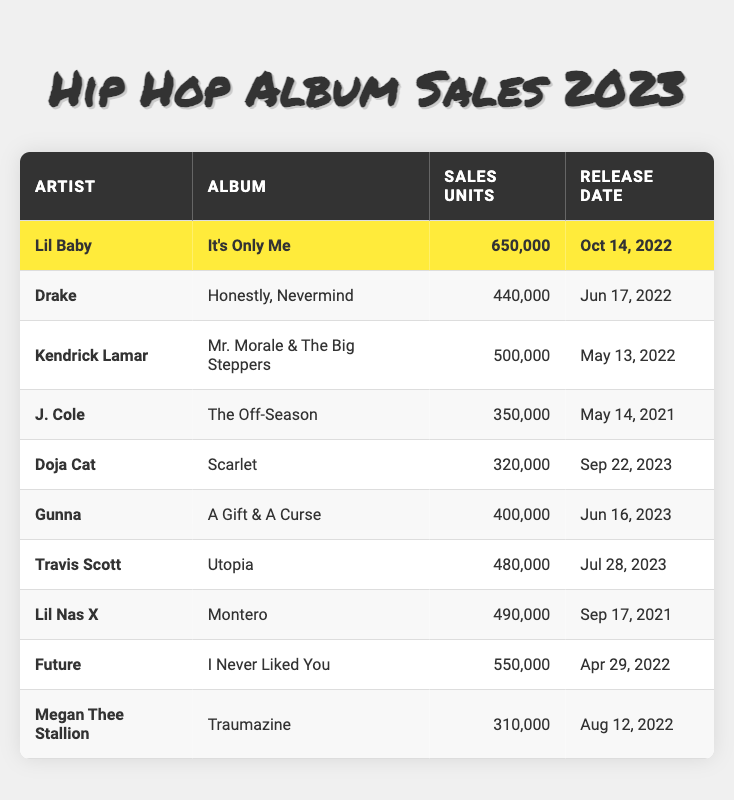What is the total number of sales units for all albums listed? To find the total sales units, I will sum the sales units for each album: 650,000 (Lil Baby) + 440,000 (Drake) + 500,000 (Kendrick Lamar) + 350,000 (J. Cole) + 320,000 (Doja Cat) + 400,000 (Gunna) + 480,000 (Travis Scott) + 490,000 (Lil Nas X) + 550,000 (Future) + 310,000 (Megan Thee Stallion) = 4,930,000.
Answer: 4,930,000 Which album had the highest sales units? Looking through the table, I can see that "It's Only Me" by Lil Baby has 650,000 sales units, which is more than any other album listed.
Answer: It's Only Me How many albums were released in 2023? By reviewing the release dates in the table, I see that there are three albums released in 2023: "Scarlet" by Doja Cat, "A Gift & A Curse" by Gunna, and "Utopia" by Travis Scott.
Answer: 3 True or False: Travis Scott's album has more sales than Megan Thee Stallion's album. Checking the sales units, Travis Scott's "Utopia" has 480,000 sales which is more than Megan Thee Stallion's "Traumazine," which has 310,000 sales. Therefore, the statement is true.
Answer: True What is the average sales units of albums released after 2022? The albums released after 2022 are "Scarlet" (320,000), "A Gift & A Curse" (400,000), and "Utopia" (480,000). First, I will sum these: 320,000 + 400,000 + 480,000 = 1,200,000. There are 3 albums, so the average is 1,200,000 / 3 = 400,000.
Answer: 400,000 Which artist has sales units closest to 500,000? I find that "Mr. Morale & The Big Steppers" by Kendrick Lamar has 500,000 sales, and "Montero" by Lil Nas X has 490,000 sales, which are the closest to 500,000.
Answer: Kendrick Lamar and Lil Nas X What is the difference in sales units between Lil Baby's and Gunna's albums? Lil Baby's "It's Only Me" has 650,000 sales and Gunna's "A Gift & A Curse" has 400,000 sales. The difference is 650,000 - 400,000 = 250,000.
Answer: 250,000 Is Megan Thee Stallion's album the lowest-selling among the listed albums? Comparing the sales units, Megan Thee Stallion's "Traumazine" has 310,000 sales, which is indeed the lowest sales compared to other albums in the table.
Answer: Yes Which hip hop artist released an album on June 16, 2023? The table shows that Gunna released "A Gift & A Curse" on June 16, 2023.
Answer: Gunna How many artists had sales units above 500,000? Reviewing the sales units, only Lil Baby with "It's Only Me" (650,000) and Future with "I Never Liked You" (550,000) have sales above 500,000. Therefore, there are 2 artists.
Answer: 2 